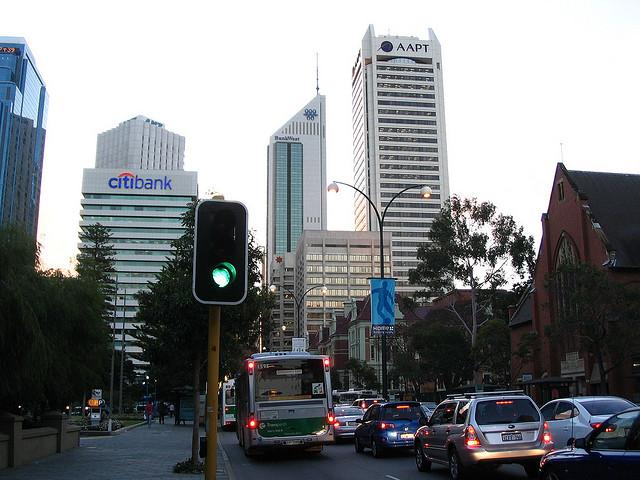Is the stop sign red?
Quick response, please. No. Where is the blue sign?
Write a very short answer. On light post. What color is the sign?
Concise answer only. Blue. Is there traffic?
Answer briefly. Yes. 